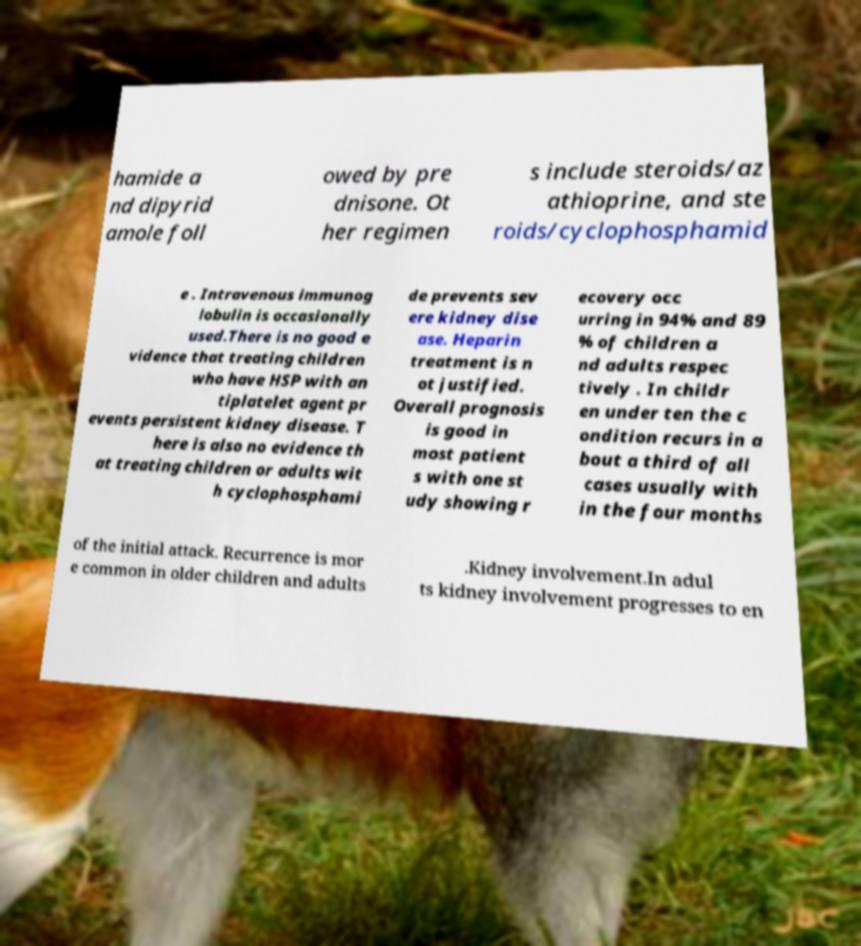What messages or text are displayed in this image? I need them in a readable, typed format. hamide a nd dipyrid amole foll owed by pre dnisone. Ot her regimen s include steroids/az athioprine, and ste roids/cyclophosphamid e . Intravenous immunog lobulin is occasionally used.There is no good e vidence that treating children who have HSP with an tiplatelet agent pr events persistent kidney disease. T here is also no evidence th at treating children or adults wit h cyclophosphami de prevents sev ere kidney dise ase. Heparin treatment is n ot justified. Overall prognosis is good in most patient s with one st udy showing r ecovery occ urring in 94% and 89 % of children a nd adults respec tively . In childr en under ten the c ondition recurs in a bout a third of all cases usually with in the four months of the initial attack. Recurrence is mor e common in older children and adults .Kidney involvement.In adul ts kidney involvement progresses to en 